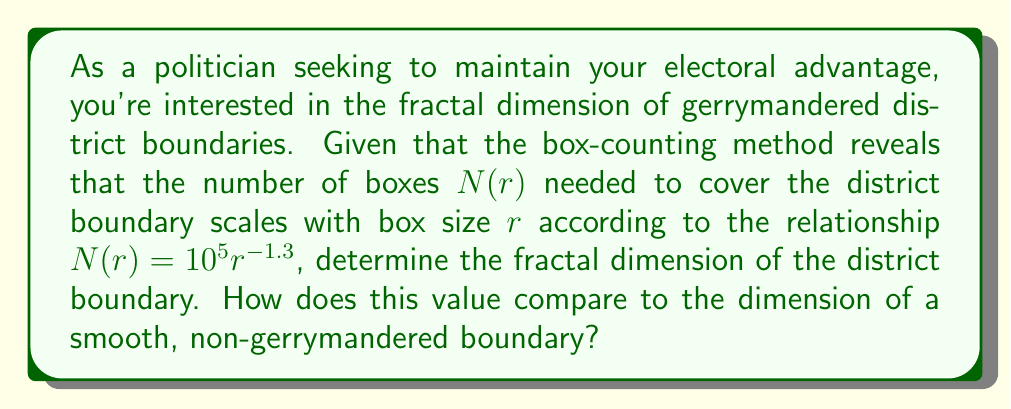Help me with this question. To solve this problem, we'll follow these steps:

1) The fractal dimension $D$ is related to the box-counting method by the equation:

   $$N(r) \propto r^{-D}$$

   where $N(r)$ is the number of boxes of size $r$ needed to cover the fractal.

2) In our case, we're given that:

   $$N(r) = 10^5 r^{-1.3}$$

3) Comparing this to the general form, we can see that the exponent -1.3 corresponds to -D:

   $$-1.3 = -D$$

4) Therefore, the fractal dimension D is simply:

   $$D = 1.3$$

5) For comparison, a smooth, non-gerrymandered boundary would have a dimension of 1, as it's a simple curve in a 2D plane.

6) The fractal dimension of 1.3 indicates that the gerrymandered boundary is more complex and space-filling than a smooth boundary, but not as complex as a fully space-filling curve (which would have a dimension of 2 in a 2D plane).
Answer: $D = 1.3$, higher than a smooth boundary (D = 1) 